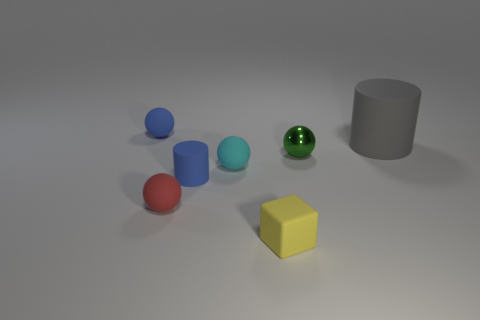Is there another yellow thing that has the same size as the yellow rubber thing?
Your answer should be very brief. No. What shape is the yellow rubber object?
Offer a terse response. Cube. How many cylinders are either yellow objects or brown objects?
Ensure brevity in your answer.  0. Is the number of big things that are behind the big cylinder the same as the number of cyan objects that are to the left of the red rubber ball?
Offer a terse response. Yes. What number of blue objects are to the right of the matte thing that is behind the rubber cylinder that is on the right side of the blue matte cylinder?
Provide a succinct answer. 1. What shape is the thing that is the same color as the tiny rubber cylinder?
Ensure brevity in your answer.  Sphere. There is a tiny cube; is its color the same as the small rubber sphere behind the large matte object?
Your answer should be very brief. No. Is the number of tiny yellow things that are on the left side of the small cyan ball greater than the number of yellow things?
Make the answer very short. No. What number of things are either small matte things that are behind the large cylinder or blue things left of the tiny blue cylinder?
Your answer should be compact. 1. What size is the gray cylinder that is made of the same material as the tiny yellow object?
Provide a succinct answer. Large. 